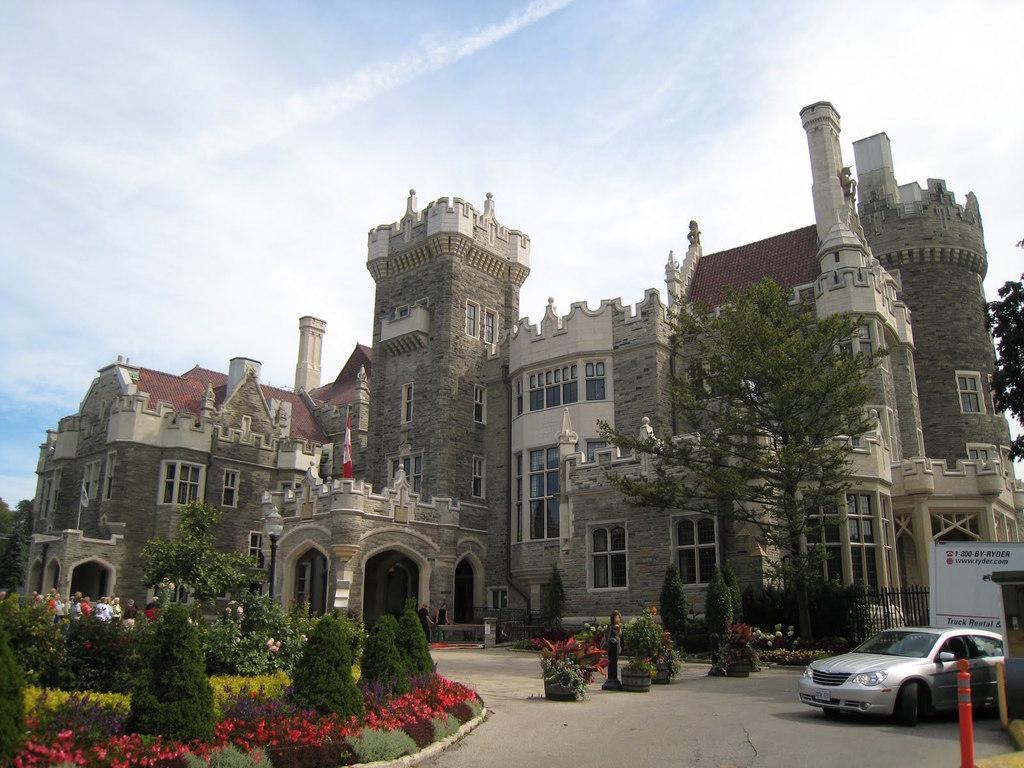Can you describe this image briefly? In this image there are some plants in the bottom of this image. There is a car on the bottom right corner of this image. There is a fencing on the top side to this car. There are some trees on the right side of this image and left side of this image as well. There is a building in the middle of this image. There is a sky on the top of this image. 